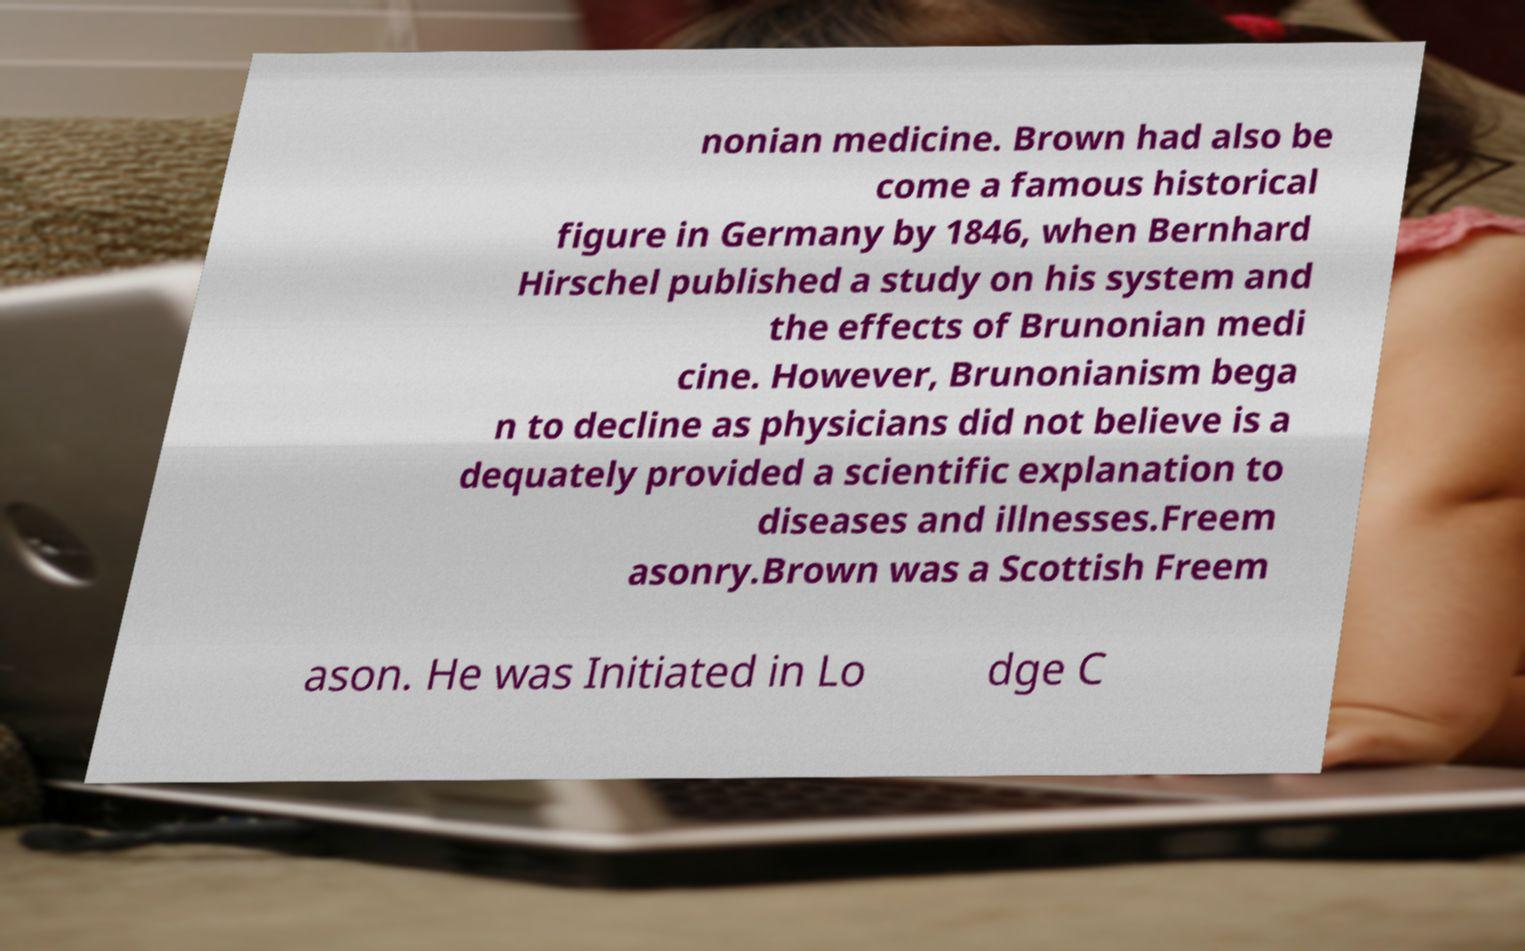There's text embedded in this image that I need extracted. Can you transcribe it verbatim? nonian medicine. Brown had also be come a famous historical figure in Germany by 1846, when Bernhard Hirschel published a study on his system and the effects of Brunonian medi cine. However, Brunonianism bega n to decline as physicians did not believe is a dequately provided a scientific explanation to diseases and illnesses.Freem asonry.Brown was a Scottish Freem ason. He was Initiated in Lo dge C 